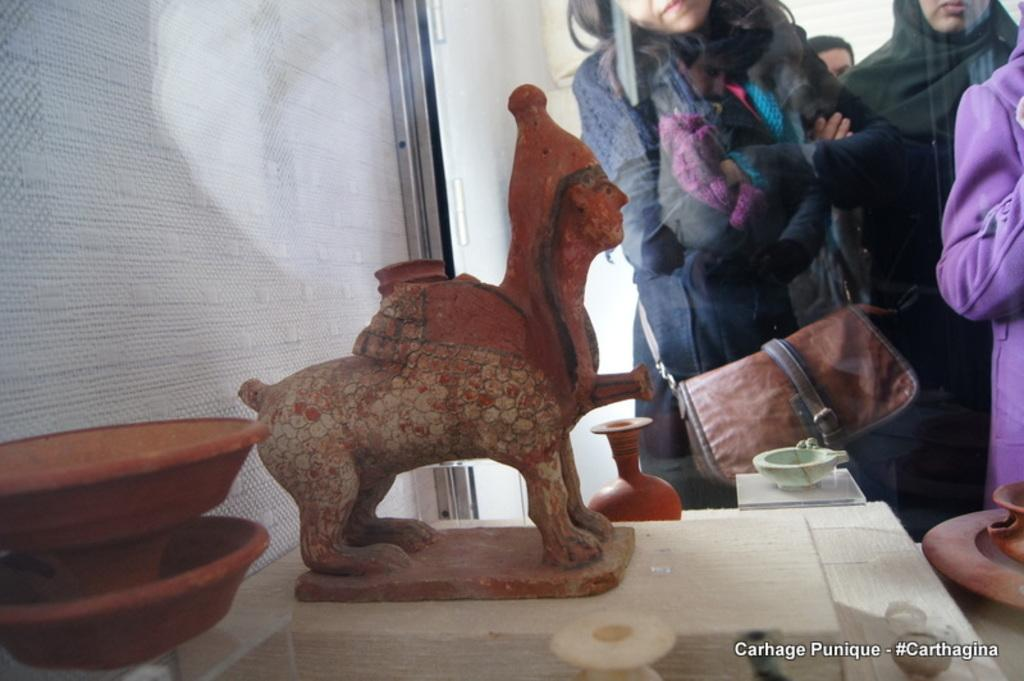What type of art can be seen in the image? There are sculptures in the image. Are there any living beings present in the image? Yes, there are people in the image. What type of fabric is used to make the quilt in the image? There is no quilt present in the image; it features sculptures and people. 